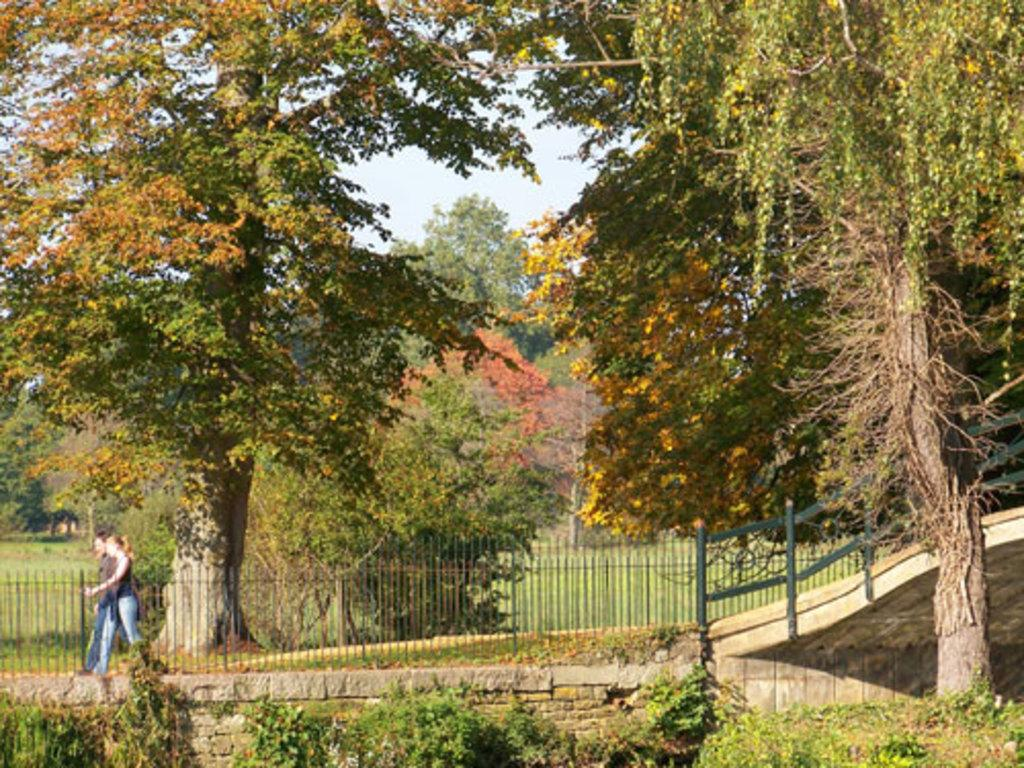What type of location is shown in the image? The image depicts a park. What natural elements can be seen in the park? There are many trees and plants in the park. What feature surrounds the park? There is fencing around the park. What activity are two people engaged in within the park? Two people are walking in the park. What is the process for building a home in the park? There is no mention of building a home in the image or the provided facts, so we cannot determine the process for doing so. 